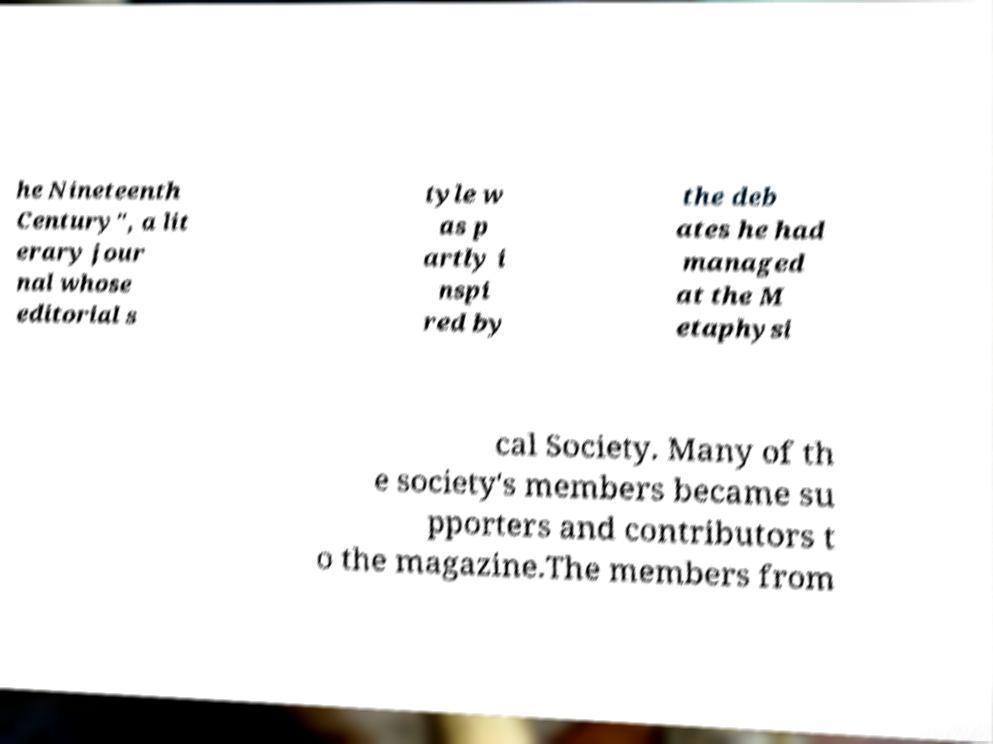For documentation purposes, I need the text within this image transcribed. Could you provide that? he Nineteenth Century", a lit erary jour nal whose editorial s tyle w as p artly i nspi red by the deb ates he had managed at the M etaphysi cal Society. Many of th e society's members became su pporters and contributors t o the magazine.The members from 